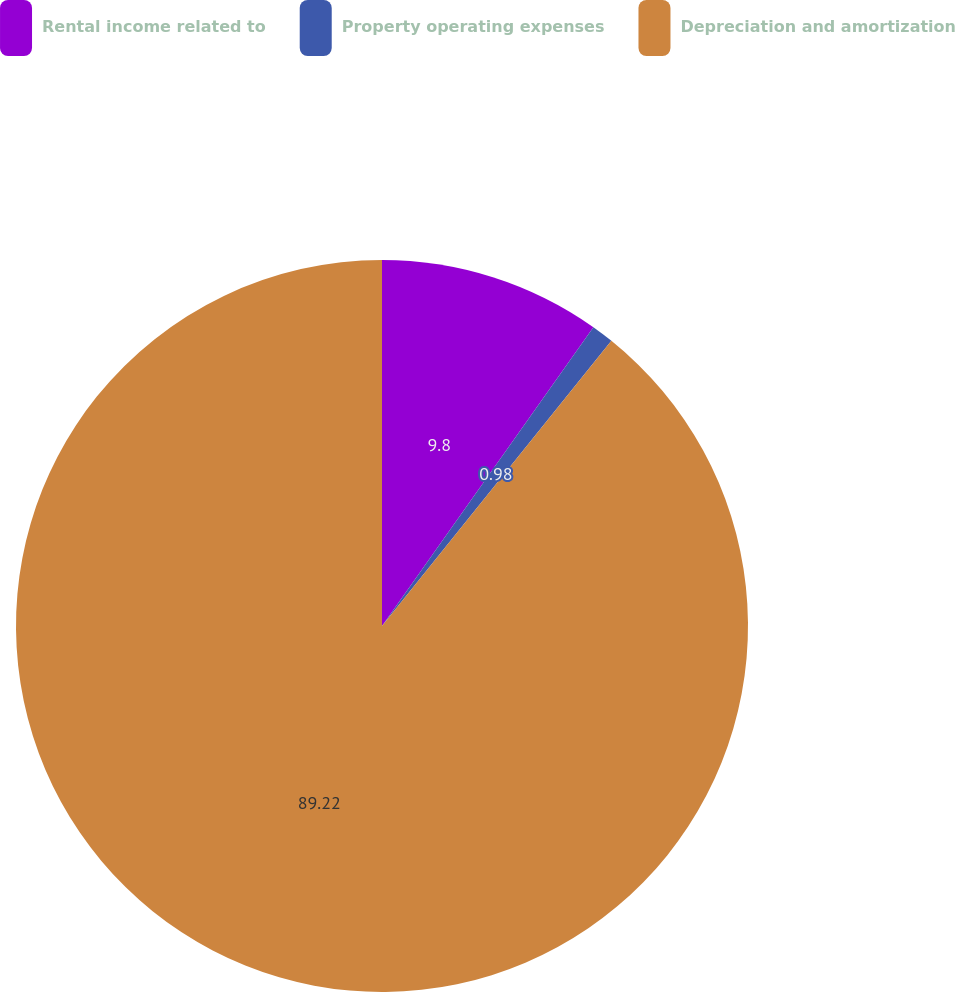Convert chart. <chart><loc_0><loc_0><loc_500><loc_500><pie_chart><fcel>Rental income related to<fcel>Property operating expenses<fcel>Depreciation and amortization<nl><fcel>9.8%<fcel>0.98%<fcel>89.22%<nl></chart> 